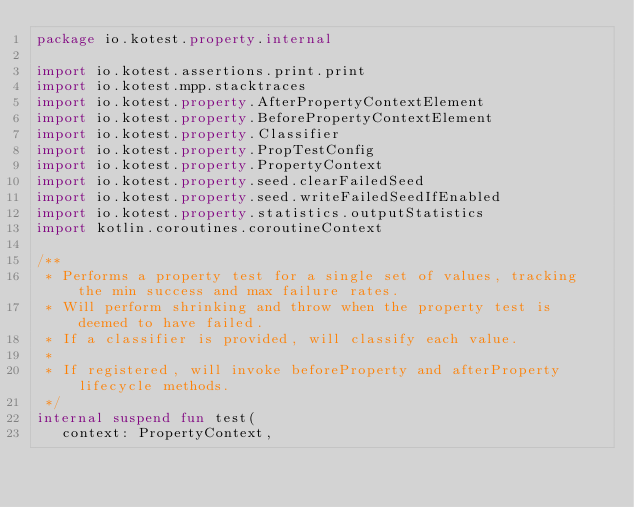<code> <loc_0><loc_0><loc_500><loc_500><_Kotlin_>package io.kotest.property.internal

import io.kotest.assertions.print.print
import io.kotest.mpp.stacktraces
import io.kotest.property.AfterPropertyContextElement
import io.kotest.property.BeforePropertyContextElement
import io.kotest.property.Classifier
import io.kotest.property.PropTestConfig
import io.kotest.property.PropertyContext
import io.kotest.property.seed.clearFailedSeed
import io.kotest.property.seed.writeFailedSeedIfEnabled
import io.kotest.property.statistics.outputStatistics
import kotlin.coroutines.coroutineContext

/**
 * Performs a property test for a single set of values, tracking the min success and max failure rates.
 * Will perform shrinking and throw when the property test is deemed to have failed.
 * If a classifier is provided, will classify each value.
 *
 * If registered, will invoke beforeProperty and afterProperty lifecycle methods.
 */
internal suspend fun test(
   context: PropertyContext,</code> 